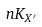<formula> <loc_0><loc_0><loc_500><loc_500>n K _ { X ^ { \prime } }</formula> 